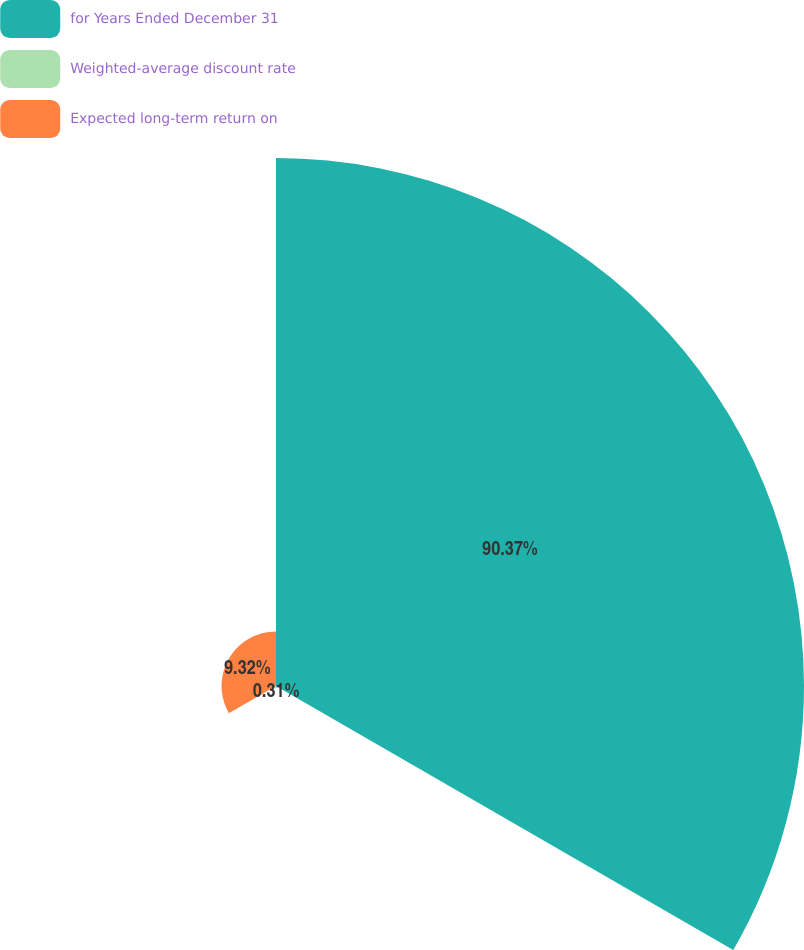Convert chart to OTSL. <chart><loc_0><loc_0><loc_500><loc_500><pie_chart><fcel>for Years Ended December 31<fcel>Weighted-average discount rate<fcel>Expected long-term return on<nl><fcel>90.37%<fcel>0.31%<fcel>9.32%<nl></chart> 